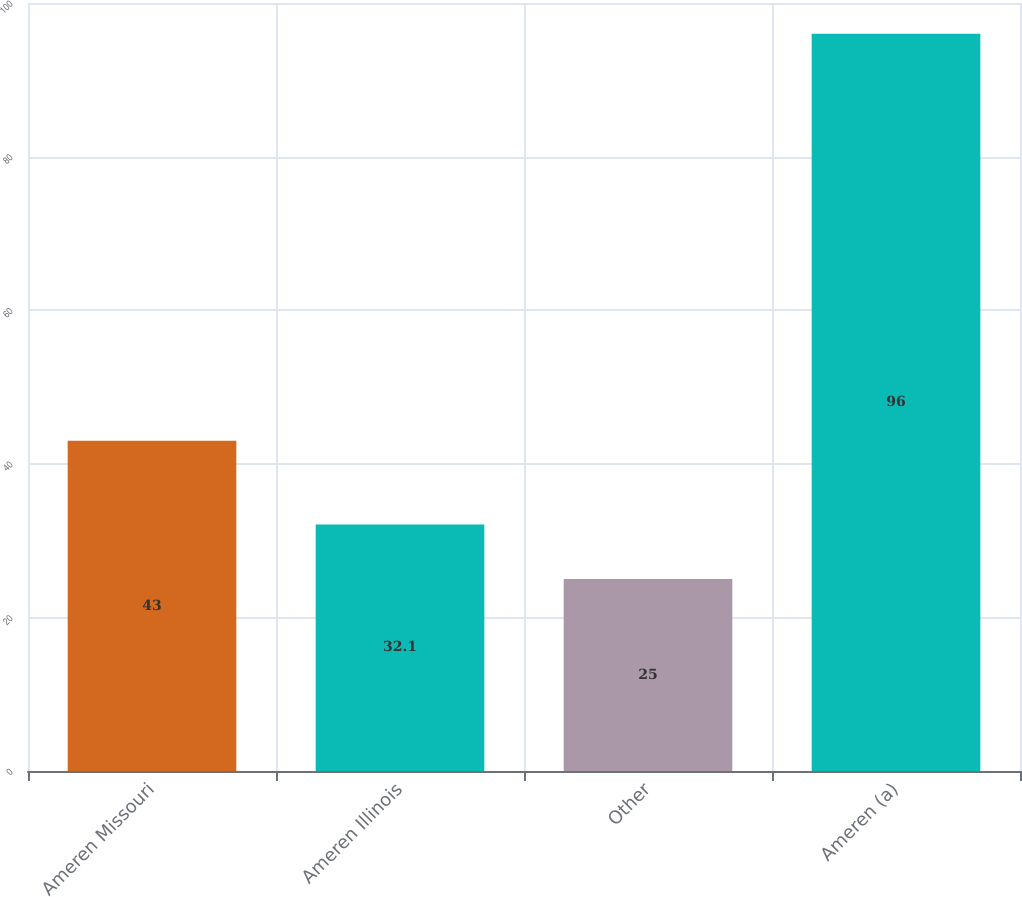Convert chart to OTSL. <chart><loc_0><loc_0><loc_500><loc_500><bar_chart><fcel>Ameren Missouri<fcel>Ameren Illinois<fcel>Other<fcel>Ameren (a)<nl><fcel>43<fcel>32.1<fcel>25<fcel>96<nl></chart> 